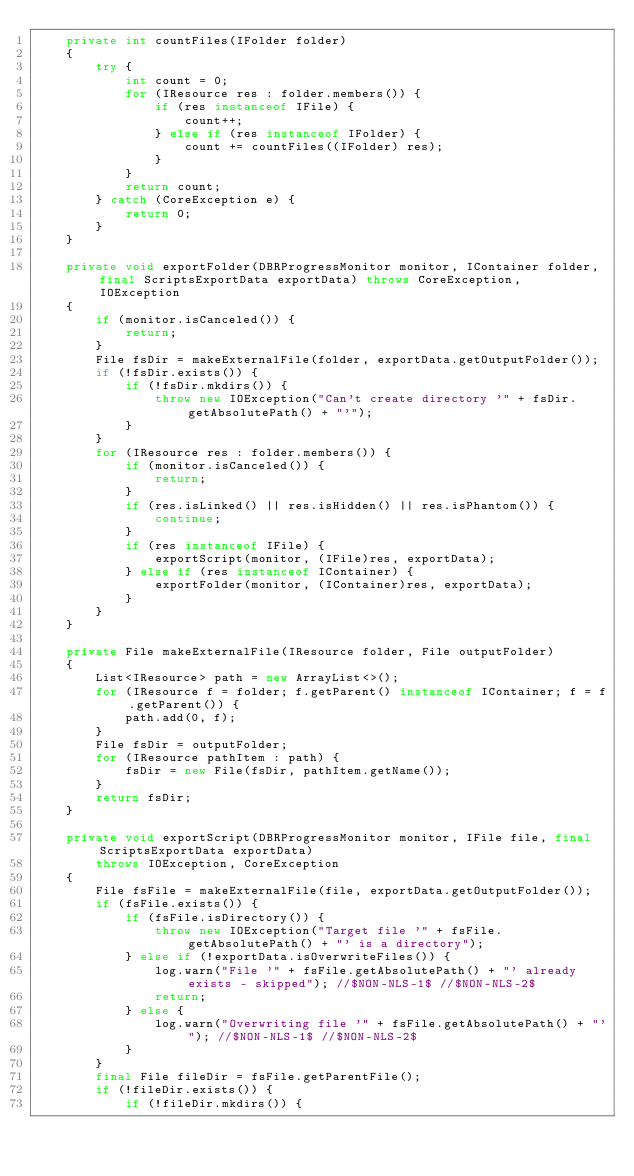Convert code to text. <code><loc_0><loc_0><loc_500><loc_500><_Java_>    private int countFiles(IFolder folder)
    {
        try {
            int count = 0;
            for (IResource res : folder.members()) {
                if (res instanceof IFile) {
                    count++;
                } else if (res instanceof IFolder) {
                    count += countFiles((IFolder) res);
                }
            }
            return count;
        } catch (CoreException e) {
            return 0;
        }
    }

    private void exportFolder(DBRProgressMonitor monitor, IContainer folder, final ScriptsExportData exportData) throws CoreException, IOException
    {
        if (monitor.isCanceled()) {
            return;
        }
        File fsDir = makeExternalFile(folder, exportData.getOutputFolder());
        if (!fsDir.exists()) {
            if (!fsDir.mkdirs()) {
                throw new IOException("Can't create directory '" + fsDir.getAbsolutePath() + "'");
            }
        }
        for (IResource res : folder.members()) {
            if (monitor.isCanceled()) {
                return;
            }
            if (res.isLinked() || res.isHidden() || res.isPhantom()) {
                continue;
            }
            if (res instanceof IFile) {
                exportScript(monitor, (IFile)res, exportData);
            } else if (res instanceof IContainer) {
                exportFolder(monitor, (IContainer)res, exportData);
            }
        }
    }

    private File makeExternalFile(IResource folder, File outputFolder)
    {
        List<IResource> path = new ArrayList<>();
        for (IResource f = folder; f.getParent() instanceof IContainer; f = f.getParent()) {
            path.add(0, f);
        }
        File fsDir = outputFolder;
        for (IResource pathItem : path) {
            fsDir = new File(fsDir, pathItem.getName());
        }
        return fsDir;
    }

    private void exportScript(DBRProgressMonitor monitor, IFile file, final ScriptsExportData exportData)
        throws IOException, CoreException
    {
        File fsFile = makeExternalFile(file, exportData.getOutputFolder());
        if (fsFile.exists()) {
            if (fsFile.isDirectory()) {
                throw new IOException("Target file '" + fsFile.getAbsolutePath() + "' is a directory");
            } else if (!exportData.isOverwriteFiles()) {
                log.warn("File '" + fsFile.getAbsolutePath() + "' already exists - skipped"); //$NON-NLS-1$ //$NON-NLS-2$
                return;
            } else {
                log.warn("Overwriting file '" + fsFile.getAbsolutePath() + "'"); //$NON-NLS-1$ //$NON-NLS-2$
            }
        }
        final File fileDir = fsFile.getParentFile();
        if (!fileDir.exists()) {
            if (!fileDir.mkdirs()) {</code> 